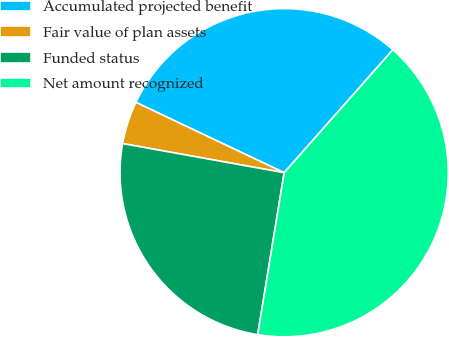Convert chart. <chart><loc_0><loc_0><loc_500><loc_500><pie_chart><fcel>Accumulated projected benefit<fcel>Fair value of plan assets<fcel>Funded status<fcel>Net amount recognized<nl><fcel>29.47%<fcel>4.21%<fcel>25.26%<fcel>41.05%<nl></chart> 